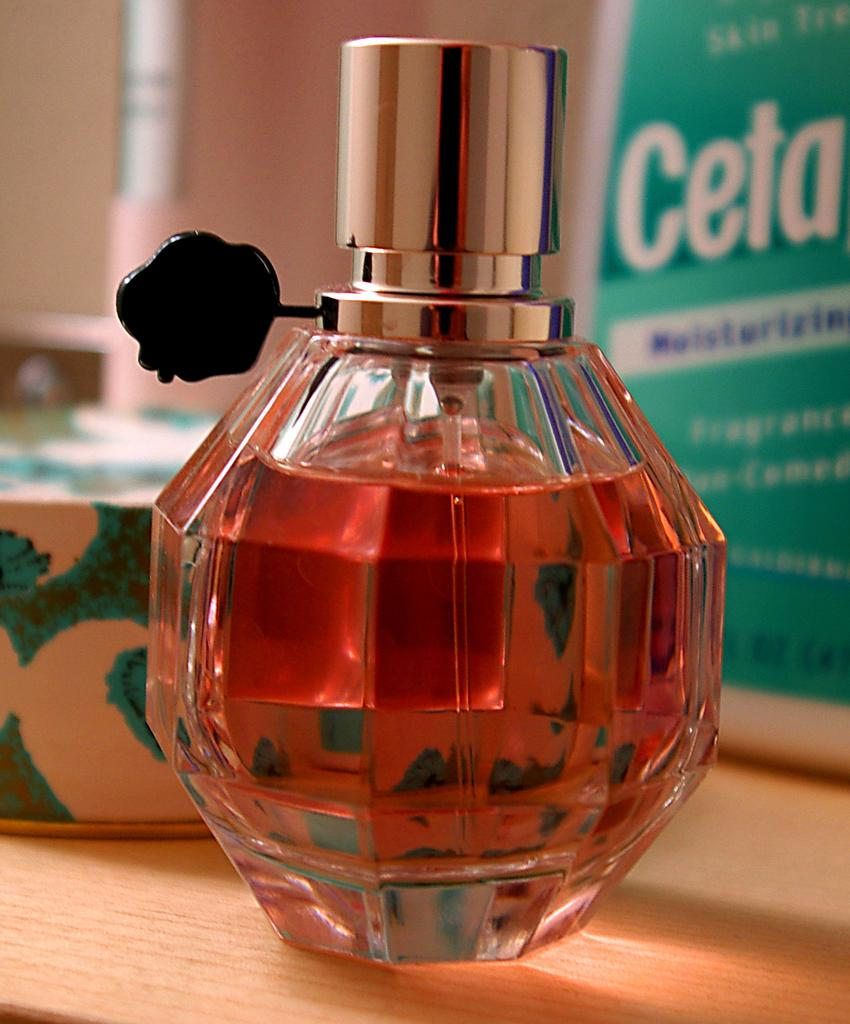<image>
Provide a brief description of the given image. The bottle of perfume sits in front of another bottle that has the letters "Ceta" 